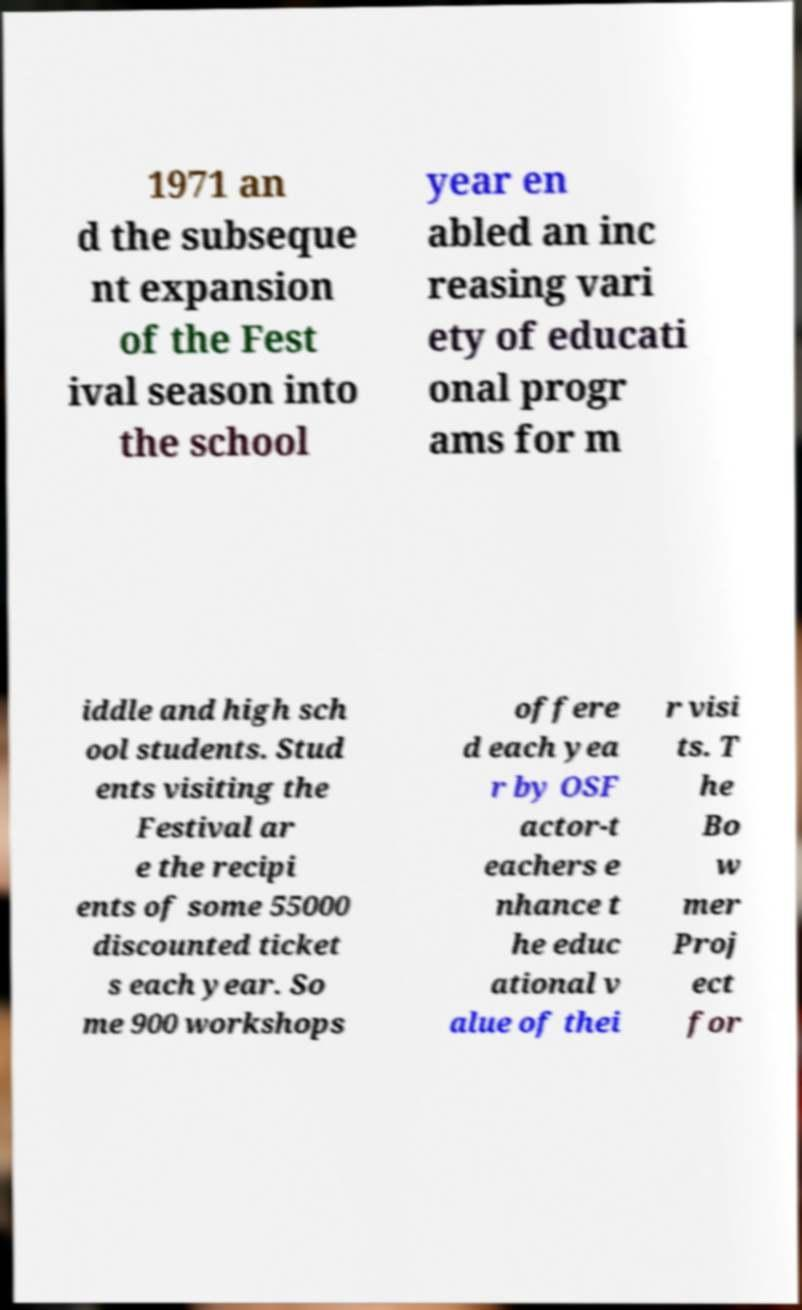Can you accurately transcribe the text from the provided image for me? 1971 an d the subseque nt expansion of the Fest ival season into the school year en abled an inc reasing vari ety of educati onal progr ams for m iddle and high sch ool students. Stud ents visiting the Festival ar e the recipi ents of some 55000 discounted ticket s each year. So me 900 workshops offere d each yea r by OSF actor-t eachers e nhance t he educ ational v alue of thei r visi ts. T he Bo w mer Proj ect for 